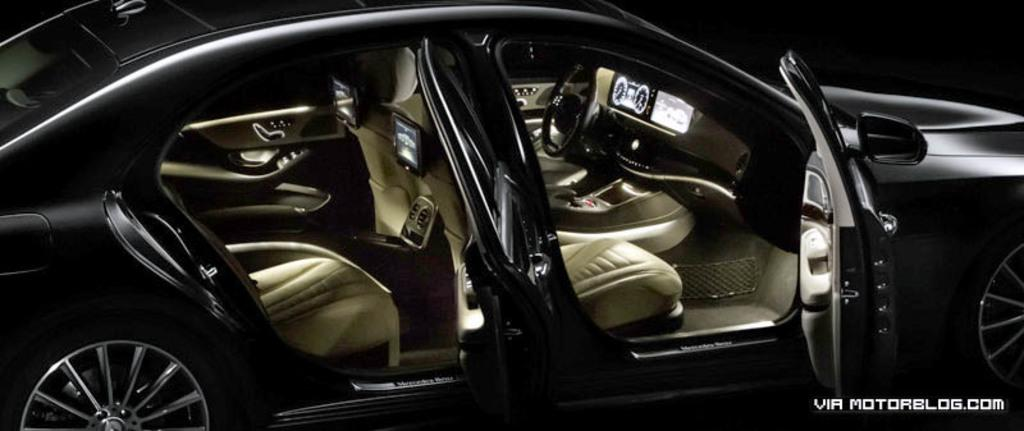What color is the car in the image? The image depicts a black car. What is located in front of the driver's seat in the car? There is a steering wheel in the car. How many screens are present in the car? There are three screens in the car. What is provided for passengers to sit on in the car? There are seats in the car. What can be seen in the bottom right corner of the image? There is text in the bottom right corner of the image. What type of soup is being served in the car? There is no soup present in the image; it depicts a car with a steering wheel, screens, seats, and text in the bottom right corner. 